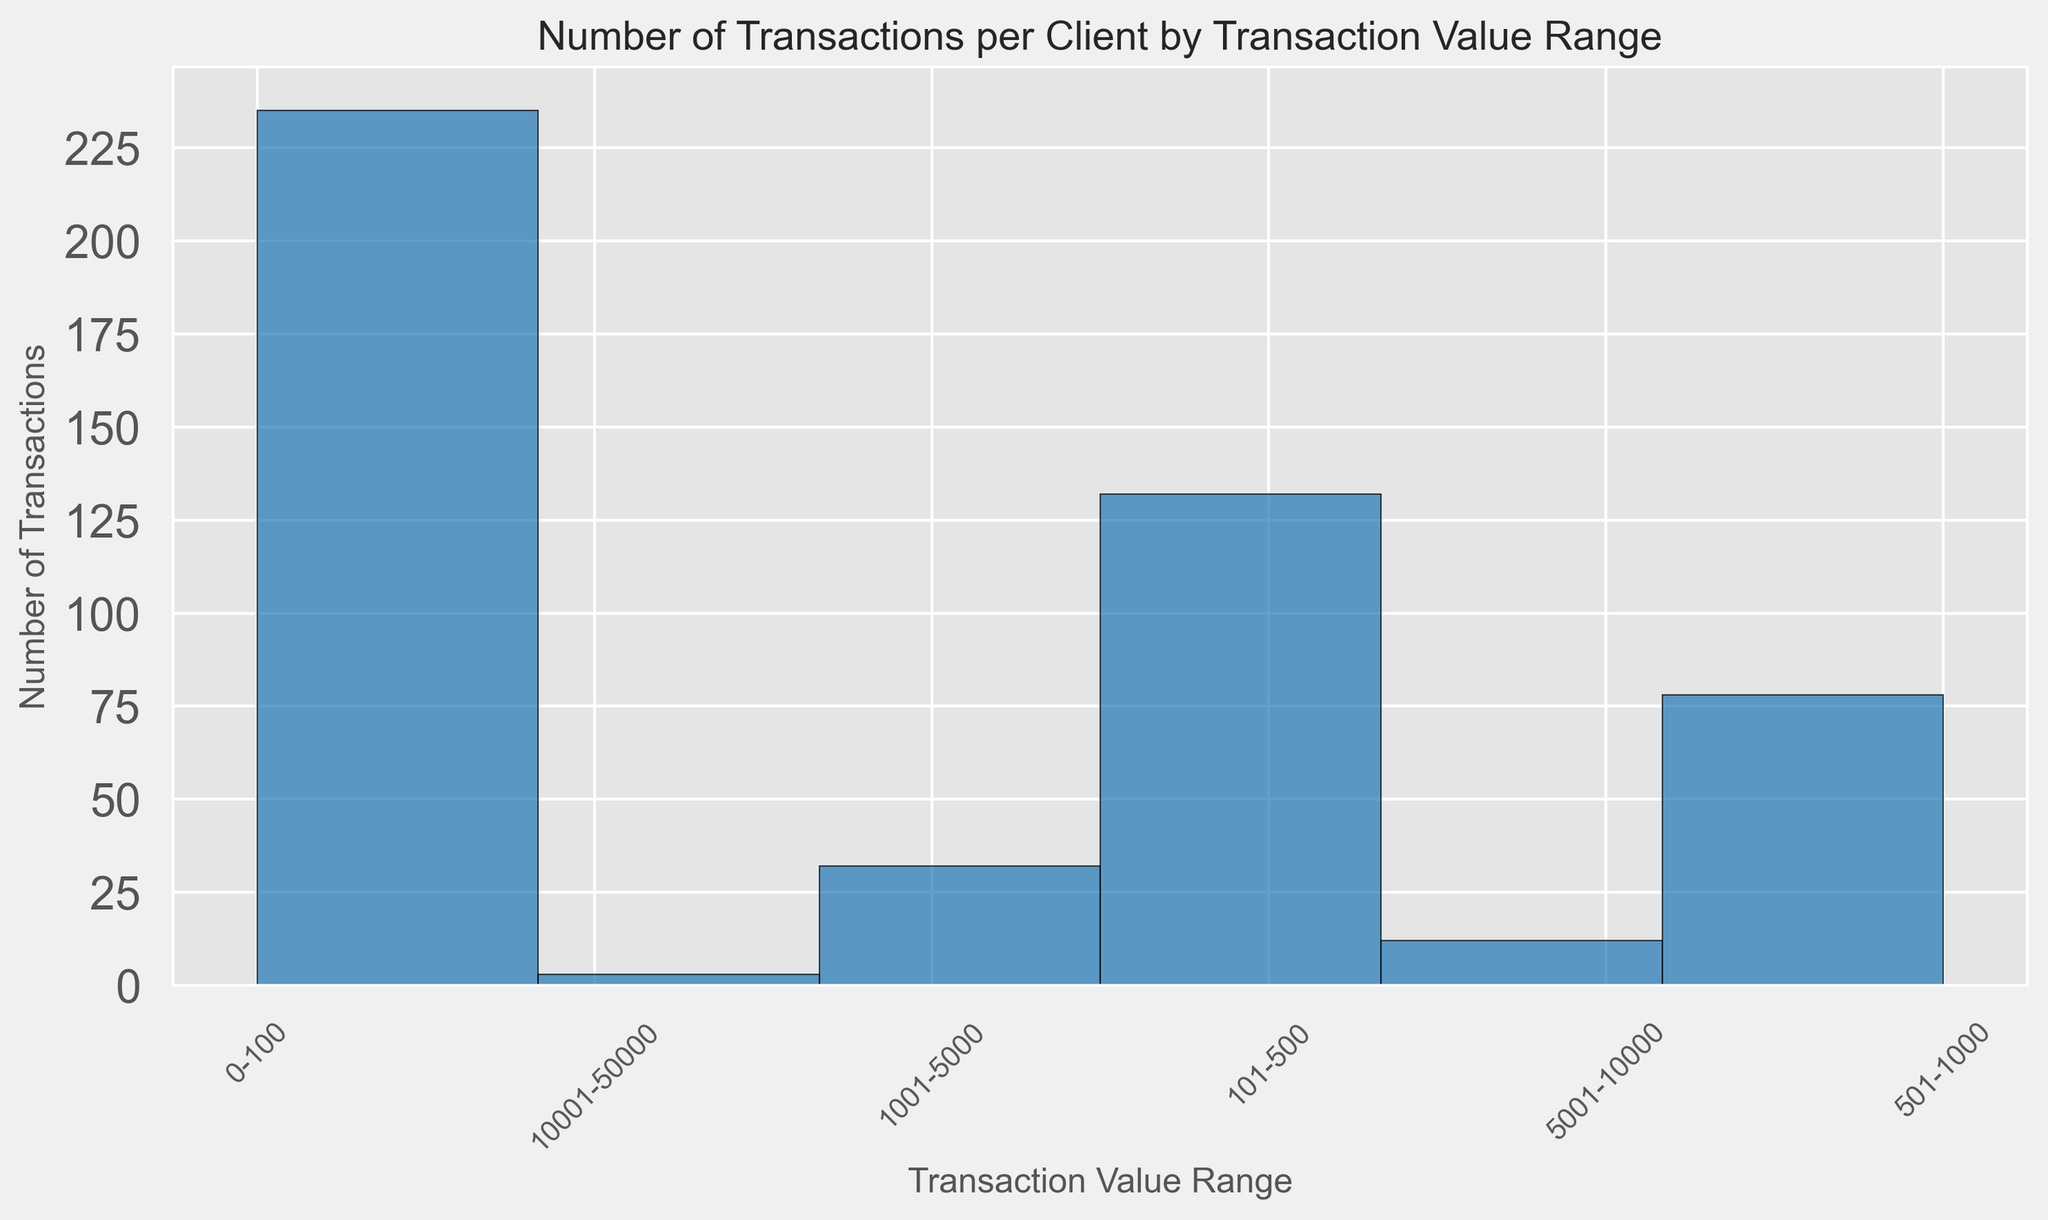How many transactions fall within the highest transaction value range? By examining the histogram bars, identify the tallest bar corresponding to the highest range and count the number of transactions. Add the values that it represents.
Answer: 3 Which transaction value range has the highest number of transactions? Look for the tallest bar in the histogram, which indicates the most frequent transaction value range. Identify the range it corresponds to.
Answer: 0-100 Compare the total number of transactions in the 101-500 range to the 501-1000 range. Which range has more transactions? Sum up the number of transactions in the 101-500 range and the 501-1000 range, then compare the two sums. The histogram bars' heights represent these sums.
Answer: 101-500 What is the total number of transactions for the range 1001-5000? Examine the height of the bar corresponding to the range 1001-5000 and add up the number of transactions it represents.
Answer: 30 How many transaction value ranges have fewer than 10 transactions? Count the number of bars in the histogram that have a height representing fewer than 10 transactions.
Answer: 1 What is the average number of transactions per client for the 501-1000 range? Sum up the number of transactions for the 501-1000 range, then divide by the number of clients (14). The bars' heights represent these sums.
Answer: 5.21 How does the number of transactions in the 5001-10000 range compare to the number in the 10001-50000 range? Examine the heights of the histogram bars for both ranges and compare them.
Answer: 5001-10000 > 10001-50000 Which client has the most transactions in the 0-100 range? From the histogram, identify the client ID associated with the bar for the 0-100 range that has the highest number of transactions.
Answer: Client05 How many clients have at least one transaction in the 5001-10000 range? Count the number of distinct bars that represent at least one transaction in the 5001-10000 range.
Answer: 8 